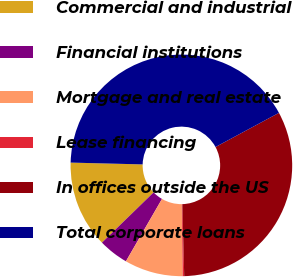Convert chart. <chart><loc_0><loc_0><loc_500><loc_500><pie_chart><fcel>Commercial and industrial<fcel>Financial institutions<fcel>Mortgage and real estate<fcel>Lease financing<fcel>In offices outside the US<fcel>Total corporate loans<nl><fcel>12.68%<fcel>4.38%<fcel>8.53%<fcel>0.22%<fcel>32.46%<fcel>41.74%<nl></chart> 